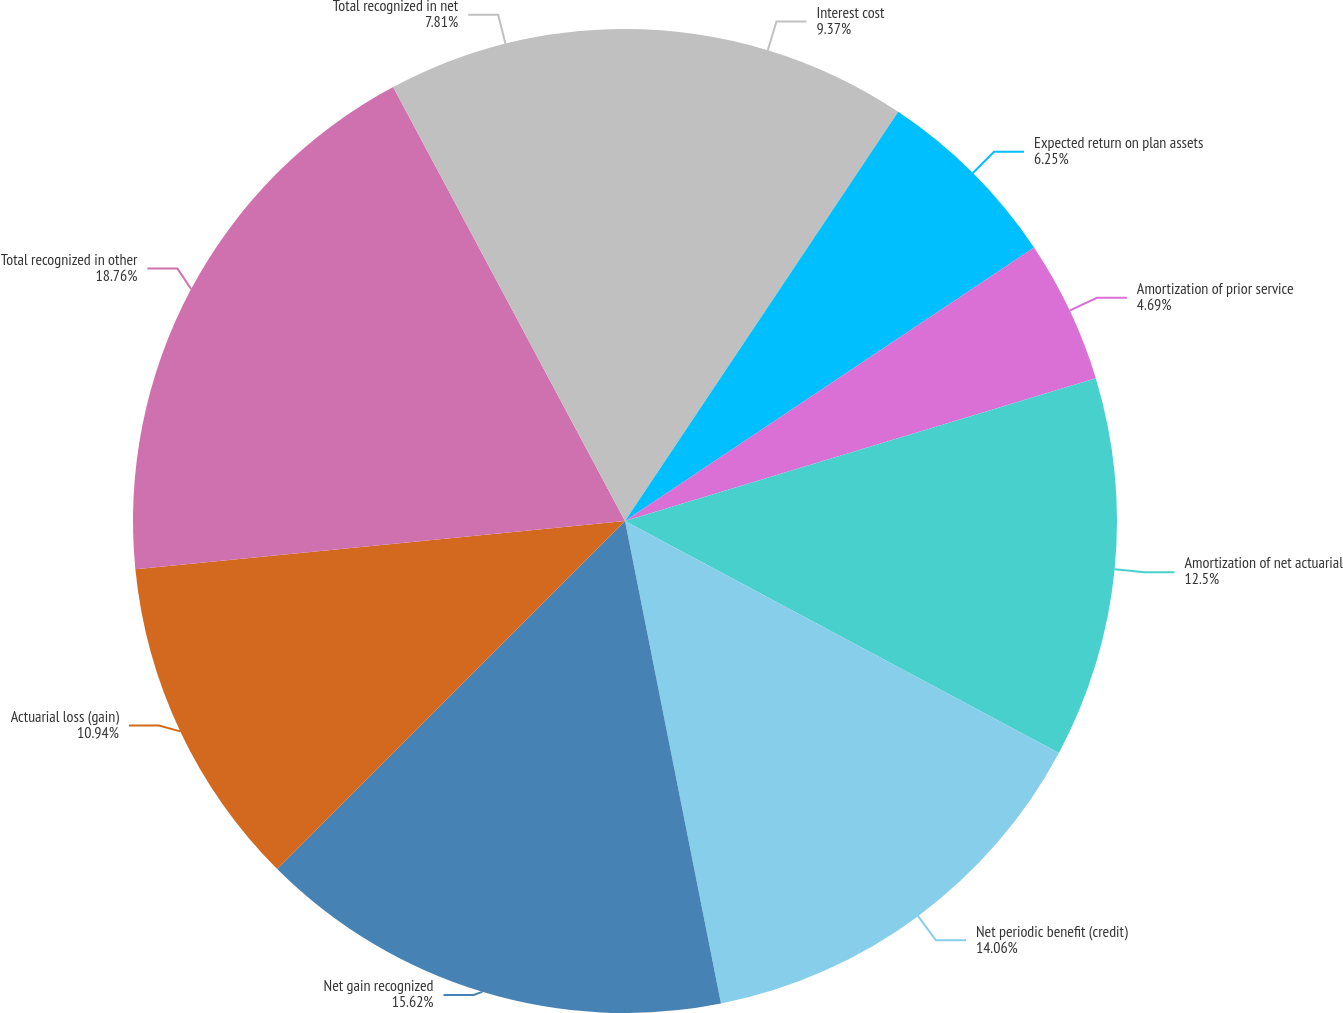Convert chart. <chart><loc_0><loc_0><loc_500><loc_500><pie_chart><fcel>Interest cost<fcel>Expected return on plan assets<fcel>Amortization of prior service<fcel>Amortization of net actuarial<fcel>Net periodic benefit (credit)<fcel>Net gain recognized<fcel>Actuarial loss (gain)<fcel>Total recognized in other<fcel>Total recognized in net<nl><fcel>9.37%<fcel>6.25%<fcel>4.69%<fcel>12.5%<fcel>14.06%<fcel>15.62%<fcel>10.94%<fcel>18.75%<fcel>7.81%<nl></chart> 